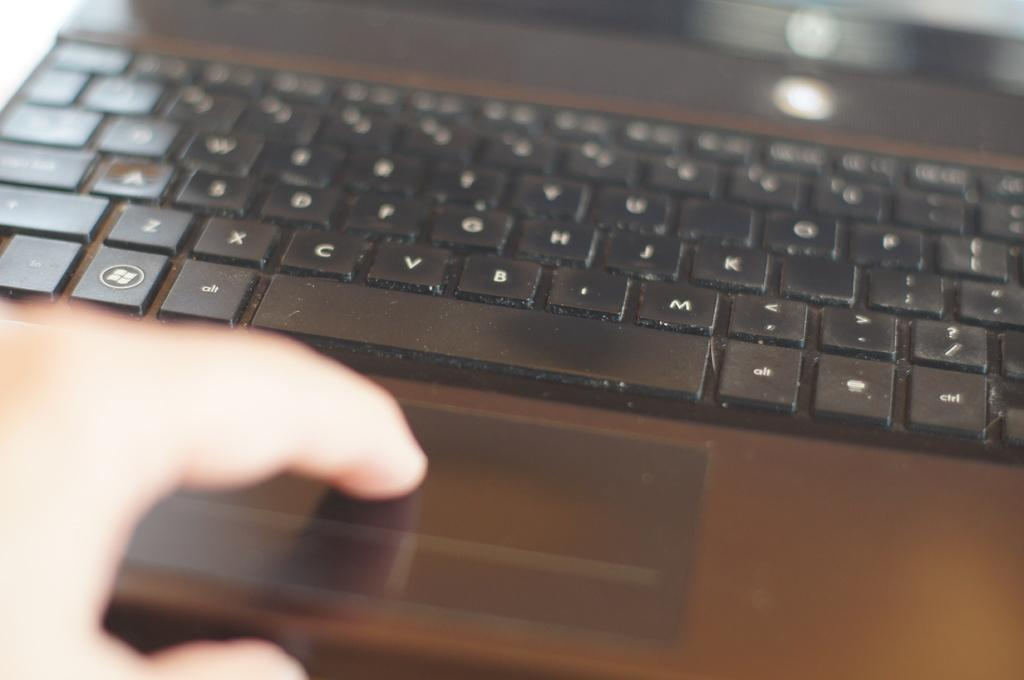<image>
Relay a brief, clear account of the picture shown. Person pressing the space bar on a laptop with an Alt key right above. 